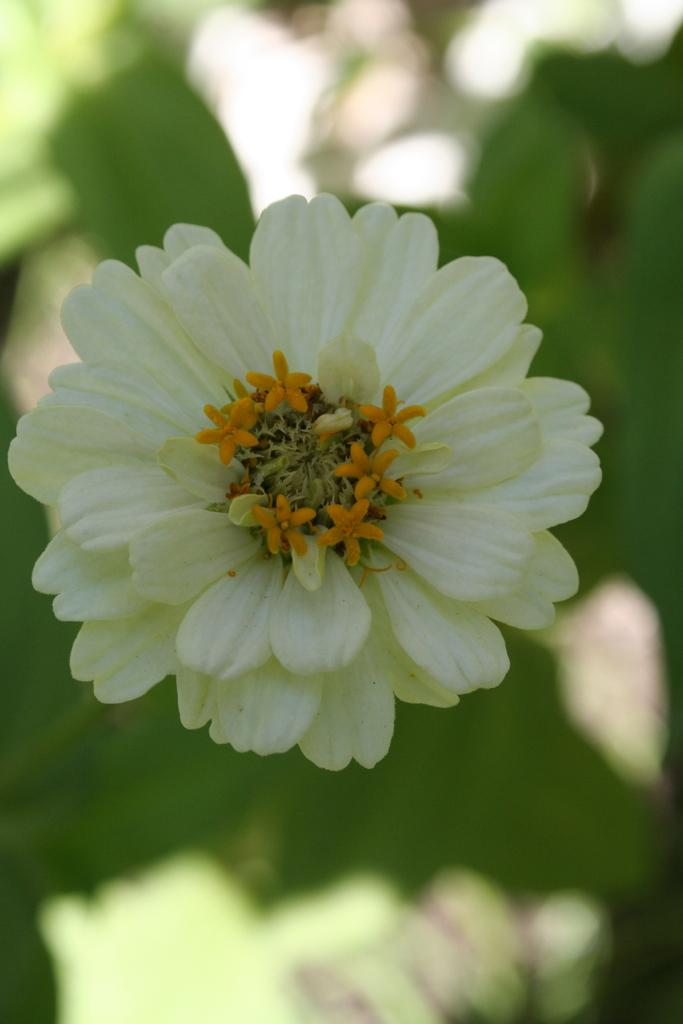What is the main subject in the front of the image? There is a flower in the front of the image. Can you describe the background of the image? The background of the image is blurry. What type of pancake is being served to the governor in the image? There is no pancake or governor present in the image; it features a flower in the foreground and a blurry background. 